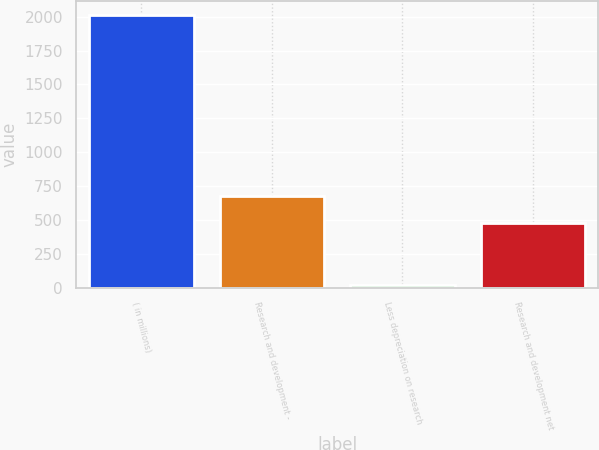Convert chart. <chart><loc_0><loc_0><loc_500><loc_500><bar_chart><fcel>( in millions)<fcel>Research and development -<fcel>Less depreciation on research<fcel>Research and development net<nl><fcel>2015<fcel>675.7<fcel>18<fcel>476<nl></chart> 